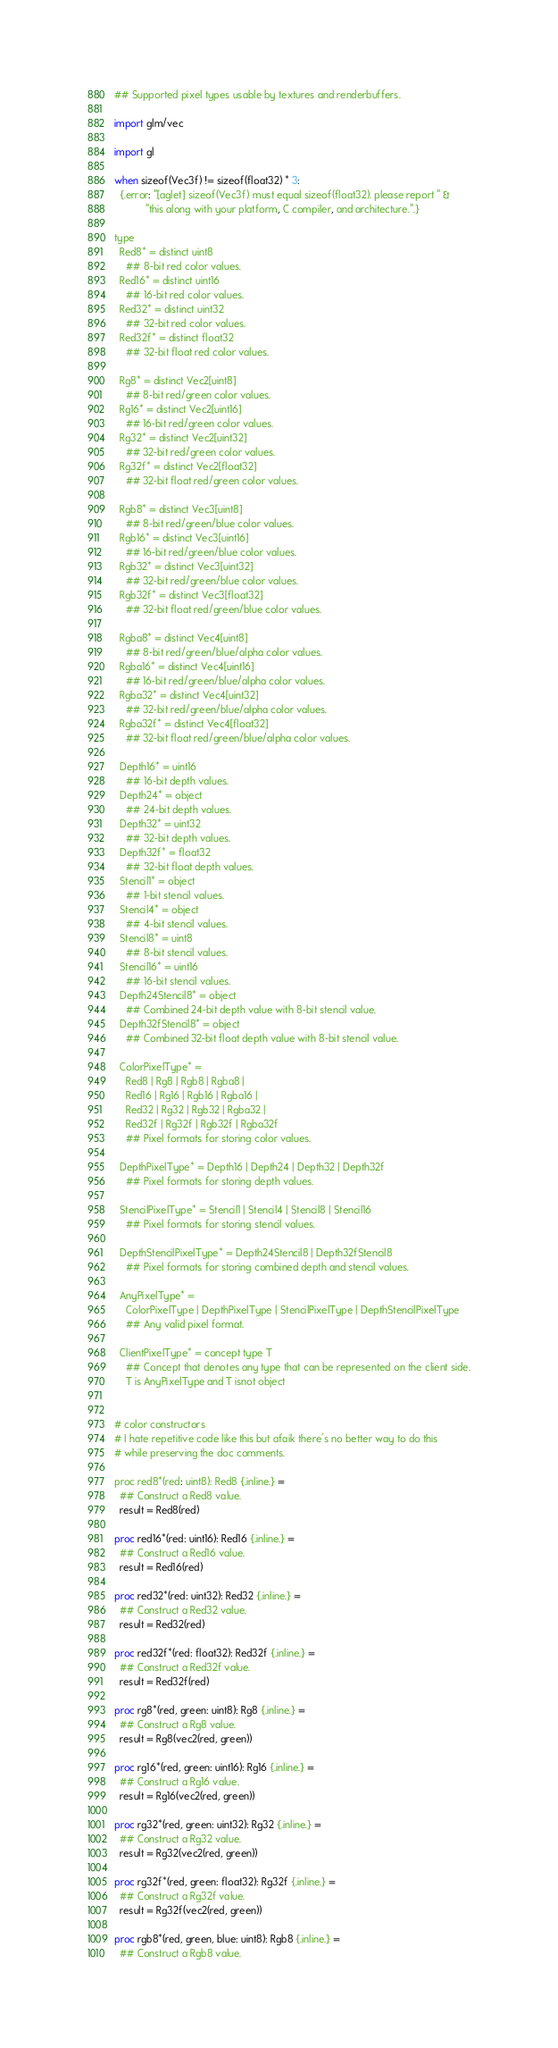<code> <loc_0><loc_0><loc_500><loc_500><_Nim_>## Supported pixel types usable by textures and renderbuffers.

import glm/vec

import gl

when sizeof(Vec3f) != sizeof(float32) * 3:
  {.error: "[aglet] sizeof(Vec3f) must equal sizeof(float32). please report " &
           "this along with your platform, C compiler, and architecture.".}

type
  Red8* = distinct uint8
    ## 8-bit red color values.
  Red16* = distinct uint16
    ## 16-bit red color values.
  Red32* = distinct uint32
    ## 32-bit red color values.
  Red32f* = distinct float32
    ## 32-bit float red color values.

  Rg8* = distinct Vec2[uint8]
    ## 8-bit red/green color values.
  Rg16* = distinct Vec2[uint16]
    ## 16-bit red/green color values.
  Rg32* = distinct Vec2[uint32]
    ## 32-bit red/green color values.
  Rg32f* = distinct Vec2[float32]
    ## 32-bit float red/green color values.

  Rgb8* = distinct Vec3[uint8]
    ## 8-bit red/green/blue color values.
  Rgb16* = distinct Vec3[uint16]
    ## 16-bit red/green/blue color values.
  Rgb32* = distinct Vec3[uint32]
    ## 32-bit red/green/blue color values.
  Rgb32f* = distinct Vec3[float32]
    ## 32-bit float red/green/blue color values.

  Rgba8* = distinct Vec4[uint8]
    ## 8-bit red/green/blue/alpha color values.
  Rgba16* = distinct Vec4[uint16]
    ## 16-bit red/green/blue/alpha color values.
  Rgba32* = distinct Vec4[uint32]
    ## 32-bit red/green/blue/alpha color values.
  Rgba32f* = distinct Vec4[float32]
    ## 32-bit float red/green/blue/alpha color values.

  Depth16* = uint16
    ## 16-bit depth values.
  Depth24* = object
    ## 24-bit depth values.
  Depth32* = uint32
    ## 32-bit depth values.
  Depth32f* = float32
    ## 32-bit float depth values.
  Stencil1* = object
    ## 1-bit stencil values.
  Stencil4* = object
    ## 4-bit stencil values.
  Stencil8* = uint8
    ## 8-bit stencil values.
  Stencil16* = uint16
    ## 16-bit stencil values.
  Depth24Stencil8* = object
    ## Combined 24-bit depth value with 8-bit stencil value.
  Depth32fStencil8* = object
    ## Combined 32-bit float depth value with 8-bit stencil value.

  ColorPixelType* =
    Red8 | Rg8 | Rgb8 | Rgba8 |
    Red16 | Rg16 | Rgb16 | Rgba16 |
    Red32 | Rg32 | Rgb32 | Rgba32 |
    Red32f | Rg32f | Rgb32f | Rgba32f
    ## Pixel formats for storing color values.

  DepthPixelType* = Depth16 | Depth24 | Depth32 | Depth32f
    ## Pixel formats for storing depth values.

  StencilPixelType* = Stencil1 | Stencil4 | Stencil8 | Stencil16
    ## Pixel formats for storing stencil values.

  DepthStencilPixelType* = Depth24Stencil8 | Depth32fStencil8
    ## Pixel formats for storing combined depth and stencil values.

  AnyPixelType* =
    ColorPixelType | DepthPixelType | StencilPixelType | DepthStencilPixelType
    ## Any valid pixel format.

  ClientPixelType* = concept type T
    ## Concept that denotes any type that can be represented on the client side.
    T is AnyPixelType and T isnot object


# color constructors
# I hate repetitive code like this but afaik there's no better way to do this
# while preserving the doc comments.

proc red8*(red: uint8): Red8 {.inline.} =
  ## Construct a Red8 value.
  result = Red8(red)

proc red16*(red: uint16): Red16 {.inline.} =
  ## Construct a Red16 value.
  result = Red16(red)

proc red32*(red: uint32): Red32 {.inline.} =
  ## Construct a Red32 value.
  result = Red32(red)

proc red32f*(red: float32): Red32f {.inline.} =
  ## Construct a Red32f value.
  result = Red32f(red)

proc rg8*(red, green: uint8): Rg8 {.inline.} =
  ## Construct a Rg8 value.
  result = Rg8(vec2(red, green))

proc rg16*(red, green: uint16): Rg16 {.inline.} =
  ## Construct a Rg16 value.
  result = Rg16(vec2(red, green))

proc rg32*(red, green: uint32): Rg32 {.inline.} =
  ## Construct a Rg32 value.
  result = Rg32(vec2(red, green))

proc rg32f*(red, green: float32): Rg32f {.inline.} =
  ## Construct a Rg32f value.
  result = Rg32f(vec2(red, green))

proc rgb8*(red, green, blue: uint8): Rgb8 {.inline.} =
  ## Construct a Rgb8 value.</code> 